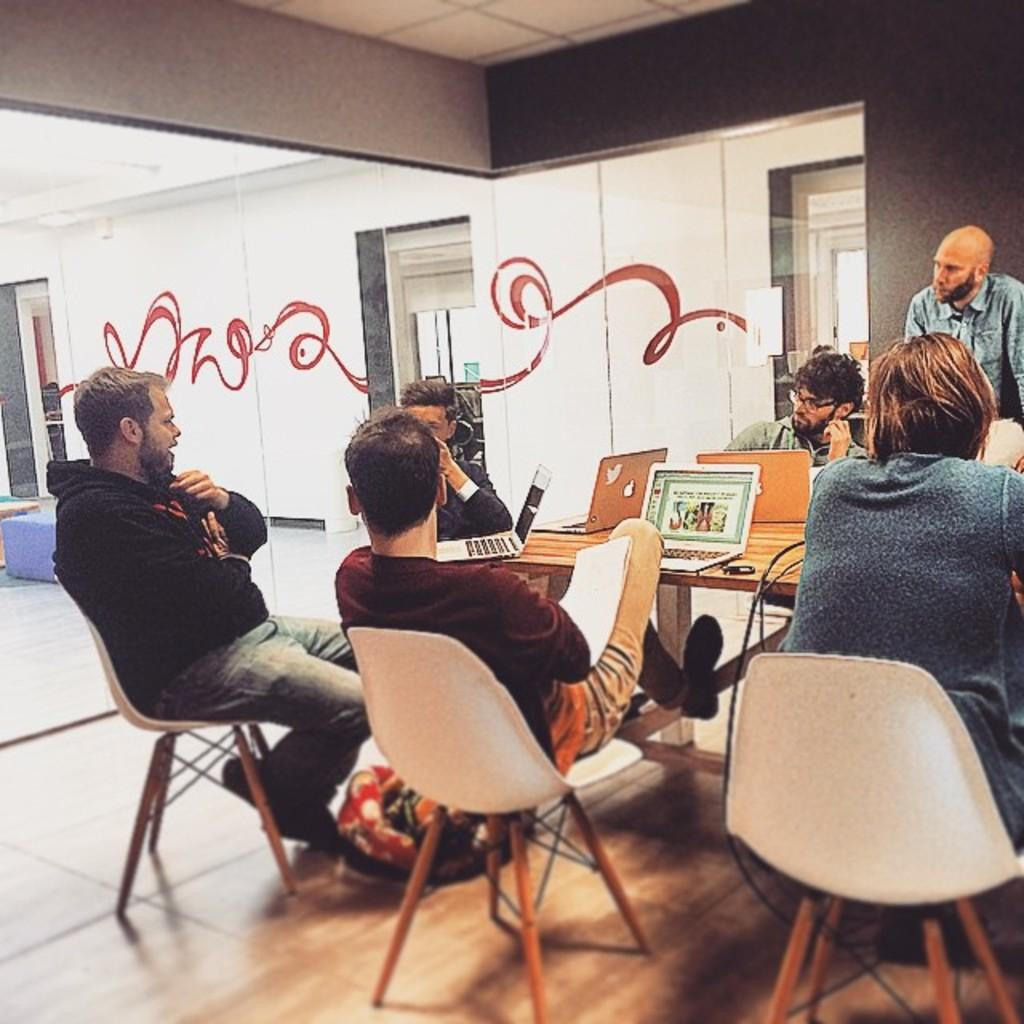What are the men in the image doing around the table? The men are sitting around the table and working on laptops. What can be seen on the wall in the background of the image? There is a painting on the wall in the background of the image. What architectural feature is visible in the background of the image? There are glass doors in the background of the image. What type of sack can be seen hanging from the ceiling in the image? There is no sack present in the image; it only features men working on laptops, a painting on the wall, and glass doors in the background. 